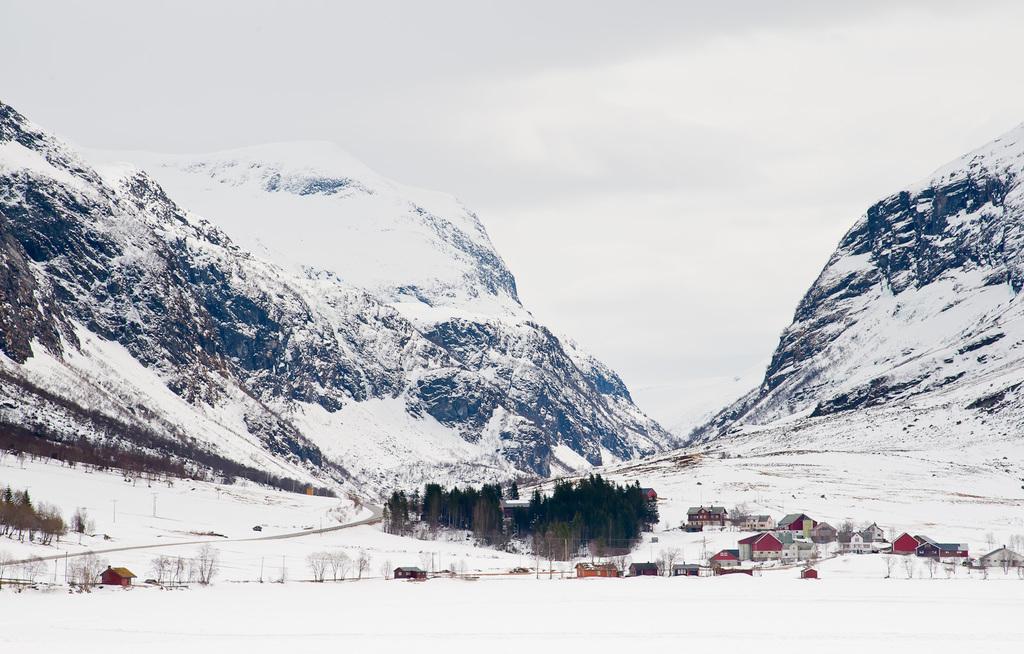Can you describe this image briefly? These are the snowy mountains. I can see the houses and the trees. 